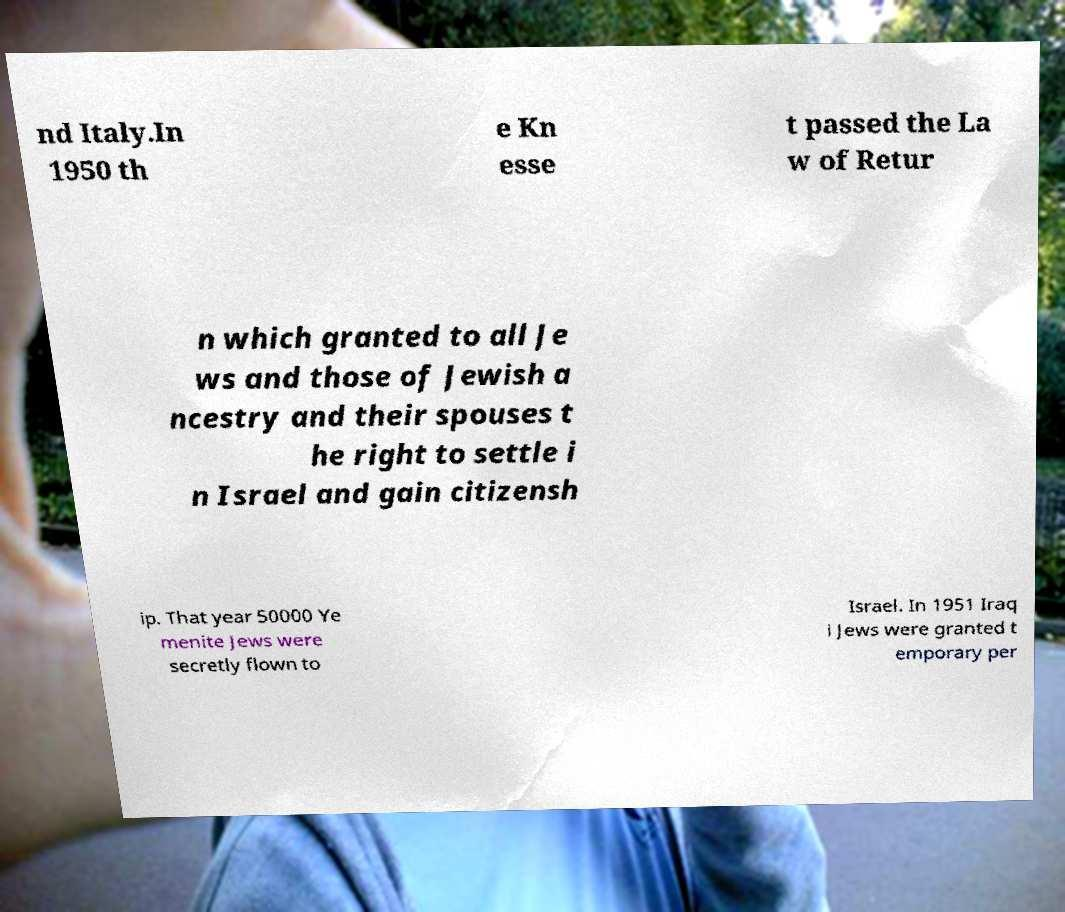Could you extract and type out the text from this image? nd Italy.In 1950 th e Kn esse t passed the La w of Retur n which granted to all Je ws and those of Jewish a ncestry and their spouses t he right to settle i n Israel and gain citizensh ip. That year 50000 Ye menite Jews were secretly flown to Israel. In 1951 Iraq i Jews were granted t emporary per 